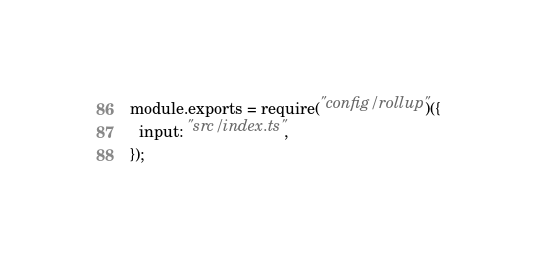Convert code to text. <code><loc_0><loc_0><loc_500><loc_500><_JavaScript_>module.exports = require("config/rollup")({
  input: "src/index.ts",
});
</code> 